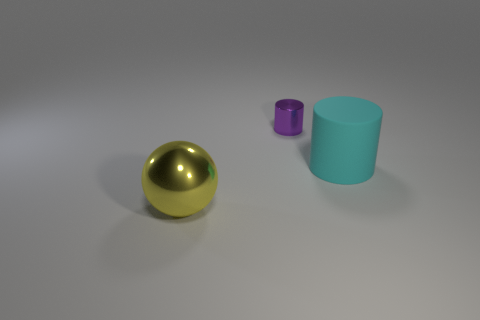What size is the shiny thing right of the shiny object in front of the big cylinder?
Offer a terse response. Small. Does the large cylinder have the same color as the large metal object?
Give a very brief answer. No. What number of metal things are either tiny red cubes or cyan objects?
Your response must be concise. 0. How many small purple cylinders are there?
Your response must be concise. 1. Is the material of the thing that is behind the big matte object the same as the large thing that is on the right side of the yellow thing?
Offer a very short reply. No. There is a tiny thing that is the same shape as the large cyan rubber thing; what is its color?
Offer a very short reply. Purple. There is a cylinder right of the cylinder to the left of the large cylinder; what is its material?
Offer a very short reply. Rubber. Does the metal object that is to the left of the purple cylinder have the same shape as the metallic thing behind the large shiny sphere?
Keep it short and to the point. No. How big is the thing that is both behind the big sphere and left of the matte cylinder?
Make the answer very short. Small. What number of other things are there of the same color as the ball?
Make the answer very short. 0. 